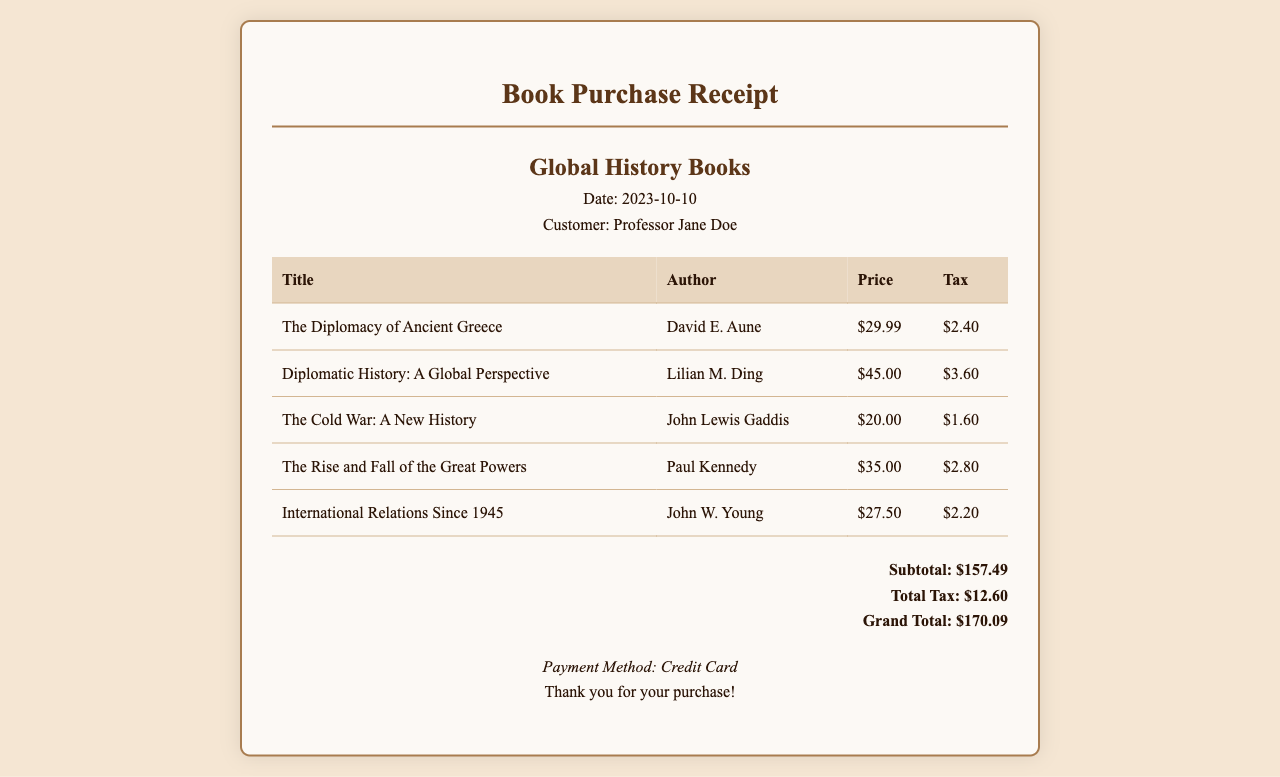What is the date of the purchase? The date of the purchase is specified in the document as the transaction date.
Answer: 2023-10-10 Who is the customer? The document provides the name of the customer who made the purchase.
Answer: Professor Jane Doe What is the price of "The Cold War: A New History"? The document lists the price for this specific title under the price column.
Answer: $20.00 How much tax was paid for the book "International Relations Since 1945"? The tax amount for this title is provided in the tax column of the receipt.
Answer: $2.20 What is the grand total of the purchase? The grand total is specified at the end of the receipt as the final amount due.
Answer: $170.09 Which book had the highest price? The prices of all books are compared to find the title with the highest price listed.
Answer: Diplomatic History: A Global Perspective What is the total tax amount for all books? The total tax accumulated from all items purchased is found in the specified section of the receipt.
Answer: $12.60 What payment method was used? The document indicates the way the payment was processed for the purchase.
Answer: Credit Card Who is the author of "The Rise and Fall of the Great Powers"? The author of this specific book is mentioned in the document as part of the purchase details.
Answer: Paul Kennedy What is the subtotal before tax? The subtotal before adding tax is provided in the total calculation section of the receipt.
Answer: $157.49 